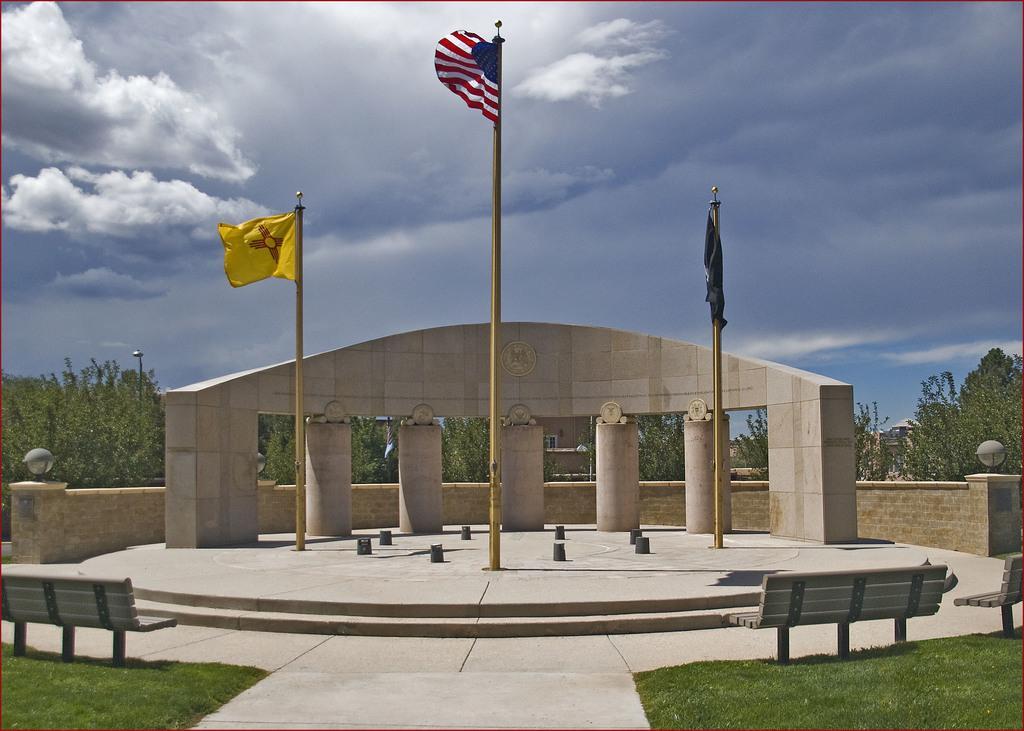Could you give a brief overview of what you see in this image? In this image can see three flags, few benches and trees on the ground. 